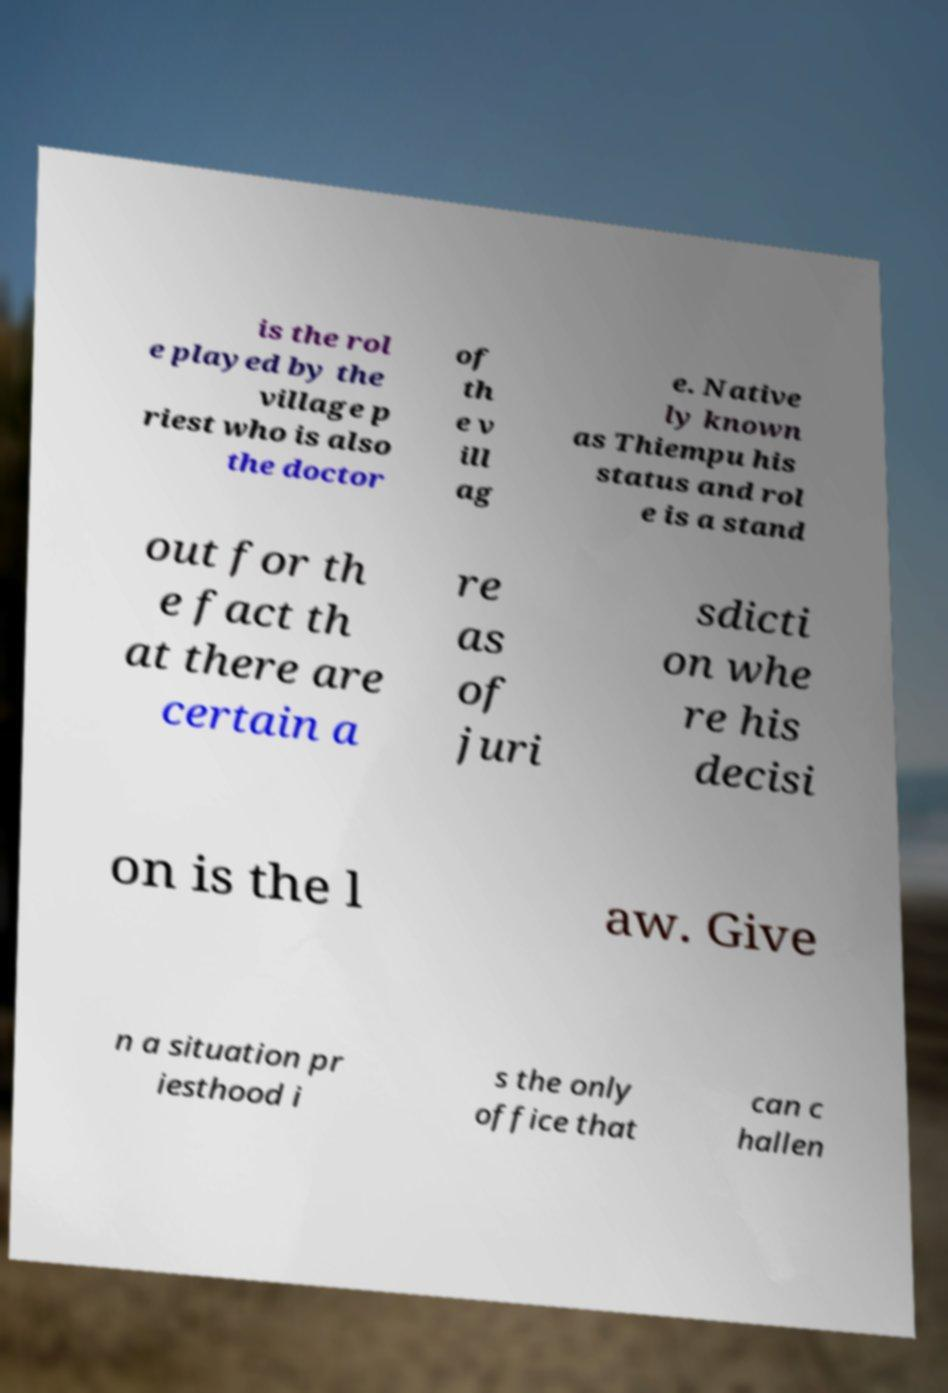What messages or text are displayed in this image? I need them in a readable, typed format. is the rol e played by the village p riest who is also the doctor of th e v ill ag e. Native ly known as Thiempu his status and rol e is a stand out for th e fact th at there are certain a re as of juri sdicti on whe re his decisi on is the l aw. Give n a situation pr iesthood i s the only office that can c hallen 